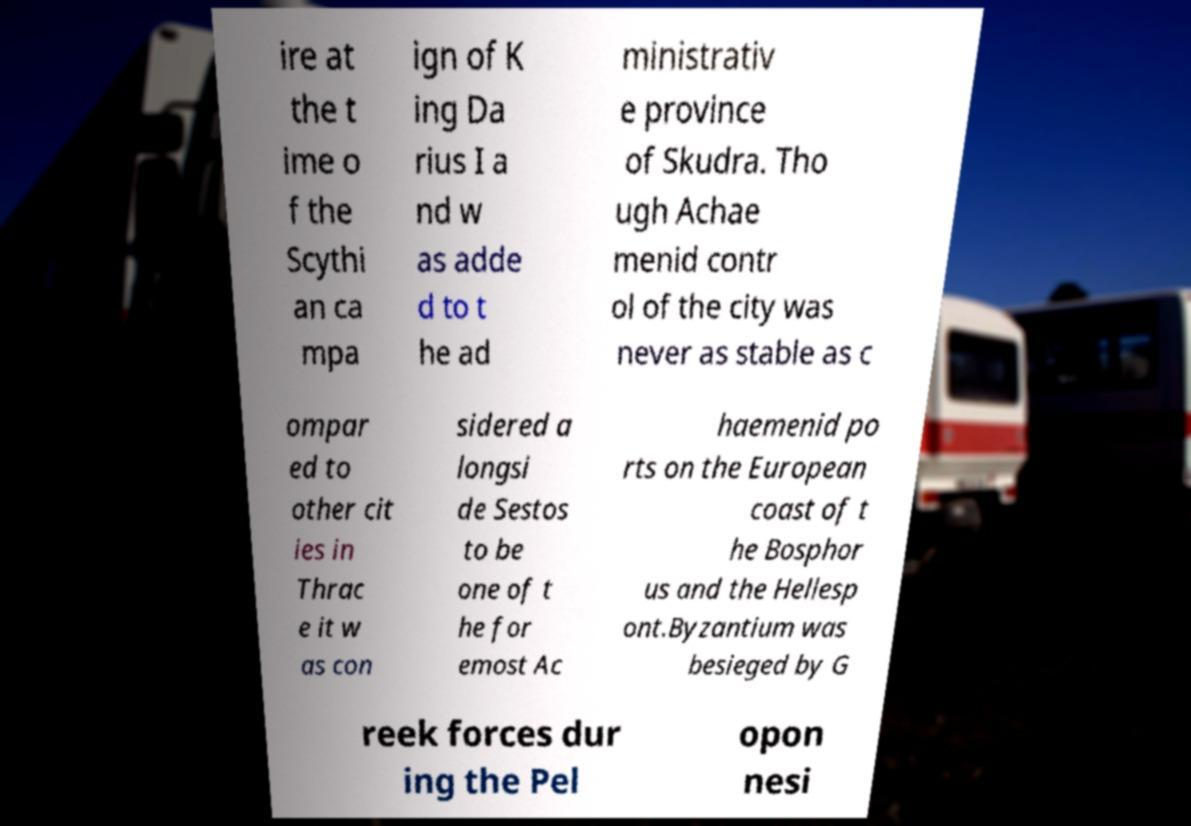Please read and relay the text visible in this image. What does it say? ire at the t ime o f the Scythi an ca mpa ign of K ing Da rius I a nd w as adde d to t he ad ministrativ e province of Skudra. Tho ugh Achae menid contr ol of the city was never as stable as c ompar ed to other cit ies in Thrac e it w as con sidered a longsi de Sestos to be one of t he for emost Ac haemenid po rts on the European coast of t he Bosphor us and the Hellesp ont.Byzantium was besieged by G reek forces dur ing the Pel opon nesi 